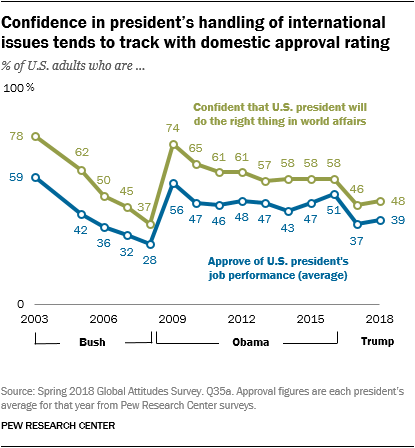Draw attention to some important aspects in this diagram. The use of colored graphs to represent data is limited to two. The ratio (A:B) of the largest value of the green graph and the smallest value of the blue graph is 1.634722222... 